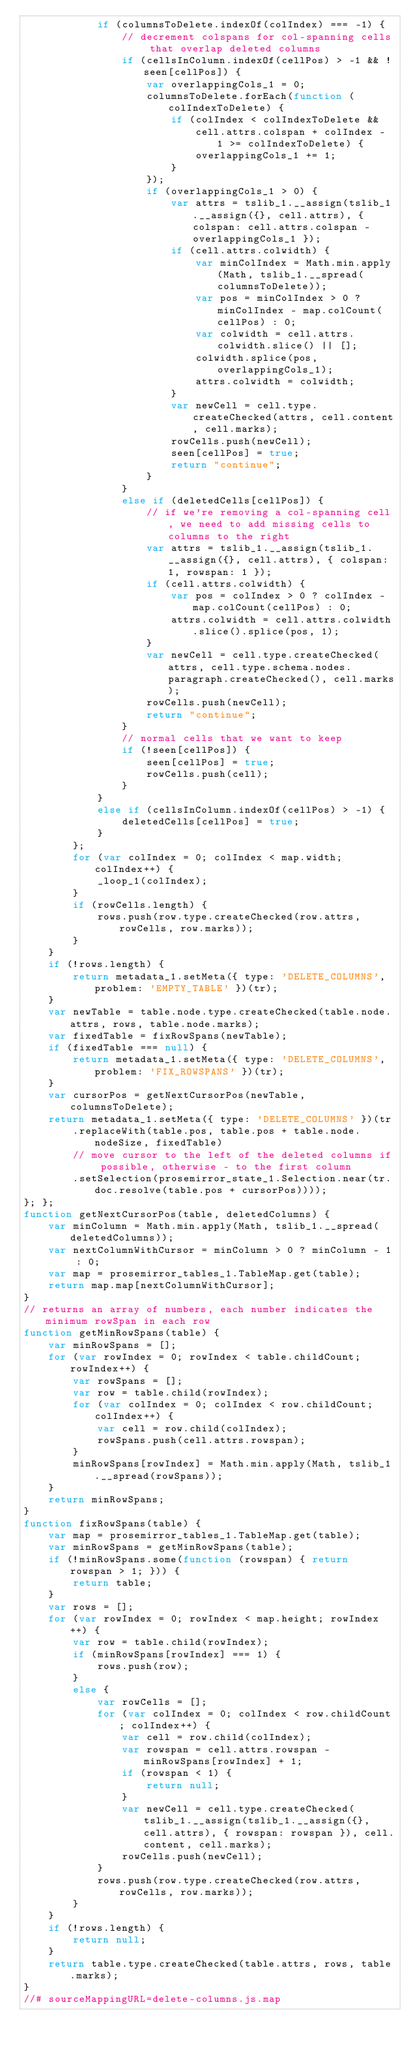Convert code to text. <code><loc_0><loc_0><loc_500><loc_500><_JavaScript_>            if (columnsToDelete.indexOf(colIndex) === -1) {
                // decrement colspans for col-spanning cells that overlap deleted columns
                if (cellsInColumn.indexOf(cellPos) > -1 && !seen[cellPos]) {
                    var overlappingCols_1 = 0;
                    columnsToDelete.forEach(function (colIndexToDelete) {
                        if (colIndex < colIndexToDelete &&
                            cell.attrs.colspan + colIndex - 1 >= colIndexToDelete) {
                            overlappingCols_1 += 1;
                        }
                    });
                    if (overlappingCols_1 > 0) {
                        var attrs = tslib_1.__assign(tslib_1.__assign({}, cell.attrs), { colspan: cell.attrs.colspan - overlappingCols_1 });
                        if (cell.attrs.colwidth) {
                            var minColIndex = Math.min.apply(Math, tslib_1.__spread(columnsToDelete));
                            var pos = minColIndex > 0 ? minColIndex - map.colCount(cellPos) : 0;
                            var colwidth = cell.attrs.colwidth.slice() || [];
                            colwidth.splice(pos, overlappingCols_1);
                            attrs.colwidth = colwidth;
                        }
                        var newCell = cell.type.createChecked(attrs, cell.content, cell.marks);
                        rowCells.push(newCell);
                        seen[cellPos] = true;
                        return "continue";
                    }
                }
                else if (deletedCells[cellPos]) {
                    // if we're removing a col-spanning cell, we need to add missing cells to columns to the right
                    var attrs = tslib_1.__assign(tslib_1.__assign({}, cell.attrs), { colspan: 1, rowspan: 1 });
                    if (cell.attrs.colwidth) {
                        var pos = colIndex > 0 ? colIndex - map.colCount(cellPos) : 0;
                        attrs.colwidth = cell.attrs.colwidth.slice().splice(pos, 1);
                    }
                    var newCell = cell.type.createChecked(attrs, cell.type.schema.nodes.paragraph.createChecked(), cell.marks);
                    rowCells.push(newCell);
                    return "continue";
                }
                // normal cells that we want to keep
                if (!seen[cellPos]) {
                    seen[cellPos] = true;
                    rowCells.push(cell);
                }
            }
            else if (cellsInColumn.indexOf(cellPos) > -1) {
                deletedCells[cellPos] = true;
            }
        };
        for (var colIndex = 0; colIndex < map.width; colIndex++) {
            _loop_1(colIndex);
        }
        if (rowCells.length) {
            rows.push(row.type.createChecked(row.attrs, rowCells, row.marks));
        }
    }
    if (!rows.length) {
        return metadata_1.setMeta({ type: 'DELETE_COLUMNS', problem: 'EMPTY_TABLE' })(tr);
    }
    var newTable = table.node.type.createChecked(table.node.attrs, rows, table.node.marks);
    var fixedTable = fixRowSpans(newTable);
    if (fixedTable === null) {
        return metadata_1.setMeta({ type: 'DELETE_COLUMNS', problem: 'FIX_ROWSPANS' })(tr);
    }
    var cursorPos = getNextCursorPos(newTable, columnsToDelete);
    return metadata_1.setMeta({ type: 'DELETE_COLUMNS' })(tr
        .replaceWith(table.pos, table.pos + table.node.nodeSize, fixedTable)
        // move cursor to the left of the deleted columns if possible, otherwise - to the first column
        .setSelection(prosemirror_state_1.Selection.near(tr.doc.resolve(table.pos + cursorPos))));
}; };
function getNextCursorPos(table, deletedColumns) {
    var minColumn = Math.min.apply(Math, tslib_1.__spread(deletedColumns));
    var nextColumnWithCursor = minColumn > 0 ? minColumn - 1 : 0;
    var map = prosemirror_tables_1.TableMap.get(table);
    return map.map[nextColumnWithCursor];
}
// returns an array of numbers, each number indicates the minimum rowSpan in each row
function getMinRowSpans(table) {
    var minRowSpans = [];
    for (var rowIndex = 0; rowIndex < table.childCount; rowIndex++) {
        var rowSpans = [];
        var row = table.child(rowIndex);
        for (var colIndex = 0; colIndex < row.childCount; colIndex++) {
            var cell = row.child(colIndex);
            rowSpans.push(cell.attrs.rowspan);
        }
        minRowSpans[rowIndex] = Math.min.apply(Math, tslib_1.__spread(rowSpans));
    }
    return minRowSpans;
}
function fixRowSpans(table) {
    var map = prosemirror_tables_1.TableMap.get(table);
    var minRowSpans = getMinRowSpans(table);
    if (!minRowSpans.some(function (rowspan) { return rowspan > 1; })) {
        return table;
    }
    var rows = [];
    for (var rowIndex = 0; rowIndex < map.height; rowIndex++) {
        var row = table.child(rowIndex);
        if (minRowSpans[rowIndex] === 1) {
            rows.push(row);
        }
        else {
            var rowCells = [];
            for (var colIndex = 0; colIndex < row.childCount; colIndex++) {
                var cell = row.child(colIndex);
                var rowspan = cell.attrs.rowspan - minRowSpans[rowIndex] + 1;
                if (rowspan < 1) {
                    return null;
                }
                var newCell = cell.type.createChecked(tslib_1.__assign(tslib_1.__assign({}, cell.attrs), { rowspan: rowspan }), cell.content, cell.marks);
                rowCells.push(newCell);
            }
            rows.push(row.type.createChecked(row.attrs, rowCells, row.marks));
        }
    }
    if (!rows.length) {
        return null;
    }
    return table.type.createChecked(table.attrs, rows, table.marks);
}
//# sourceMappingURL=delete-columns.js.map</code> 